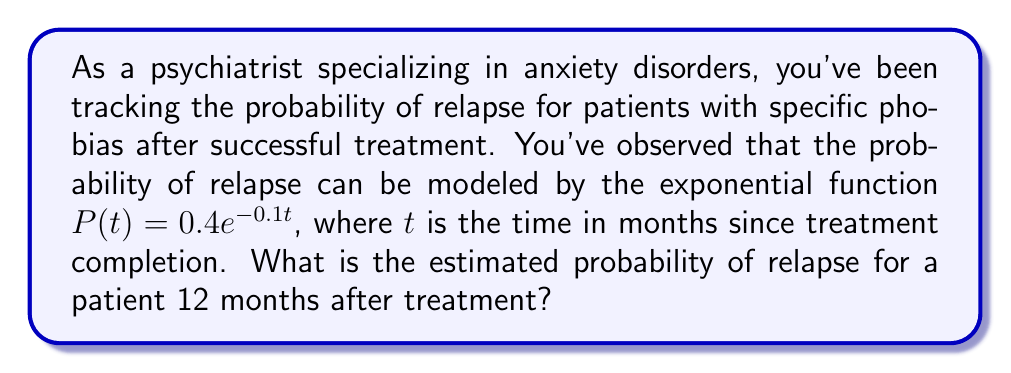Can you solve this math problem? To solve this problem, we need to follow these steps:

1. Identify the given exponential function:
   $P(t) = 0.4e^{-0.1t}$

2. Identify the time point we're interested in:
   $t = 12$ months

3. Substitute $t = 12$ into the function:
   $P(12) = 0.4e^{-0.1(12)}$

4. Simplify the exponent:
   $P(12) = 0.4e^{-1.2}$

5. Calculate the value of $e^{-1.2}$ using a calculator:
   $e^{-1.2} \approx 0.3012$

6. Multiply by 0.4:
   $P(12) = 0.4 * 0.3012 \approx 0.1205$

7. Convert to a percentage:
   $0.1205 * 100\% \approx 12.05\%$

Therefore, the estimated probability of relapse 12 months after treatment is approximately 12.05%.
Answer: 12.05% 